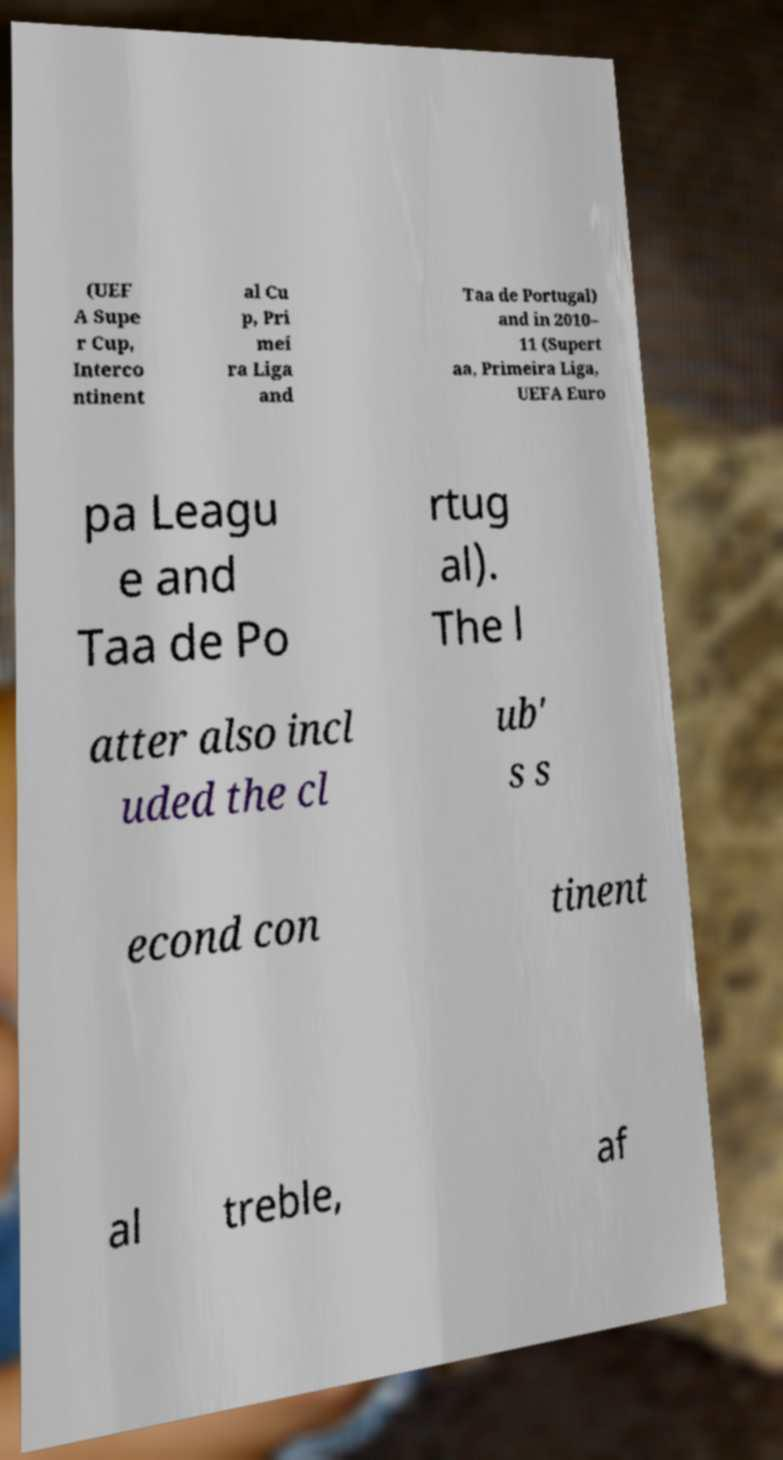Could you assist in decoding the text presented in this image and type it out clearly? (UEF A Supe r Cup, Interco ntinent al Cu p, Pri mei ra Liga and Taa de Portugal) and in 2010– 11 (Supert aa, Primeira Liga, UEFA Euro pa Leagu e and Taa de Po rtug al). The l atter also incl uded the cl ub' s s econd con tinent al treble, af 